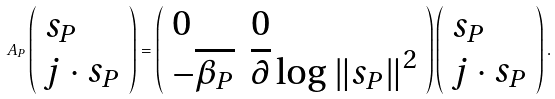Convert formula to latex. <formula><loc_0><loc_0><loc_500><loc_500>A _ { P } \left ( \begin{array} { l } s _ { P } \\ j \cdot s _ { P } \end{array} \right ) = \left ( \begin{array} { l l } 0 & 0 \\ - \overline { \beta _ { P } } & \overline { \partial } \log \left \| s _ { P } \right \| ^ { 2 } \end{array} \right ) \left ( \begin{array} { l } s _ { P } \\ j \cdot s _ { P } \end{array} \right ) .</formula> 